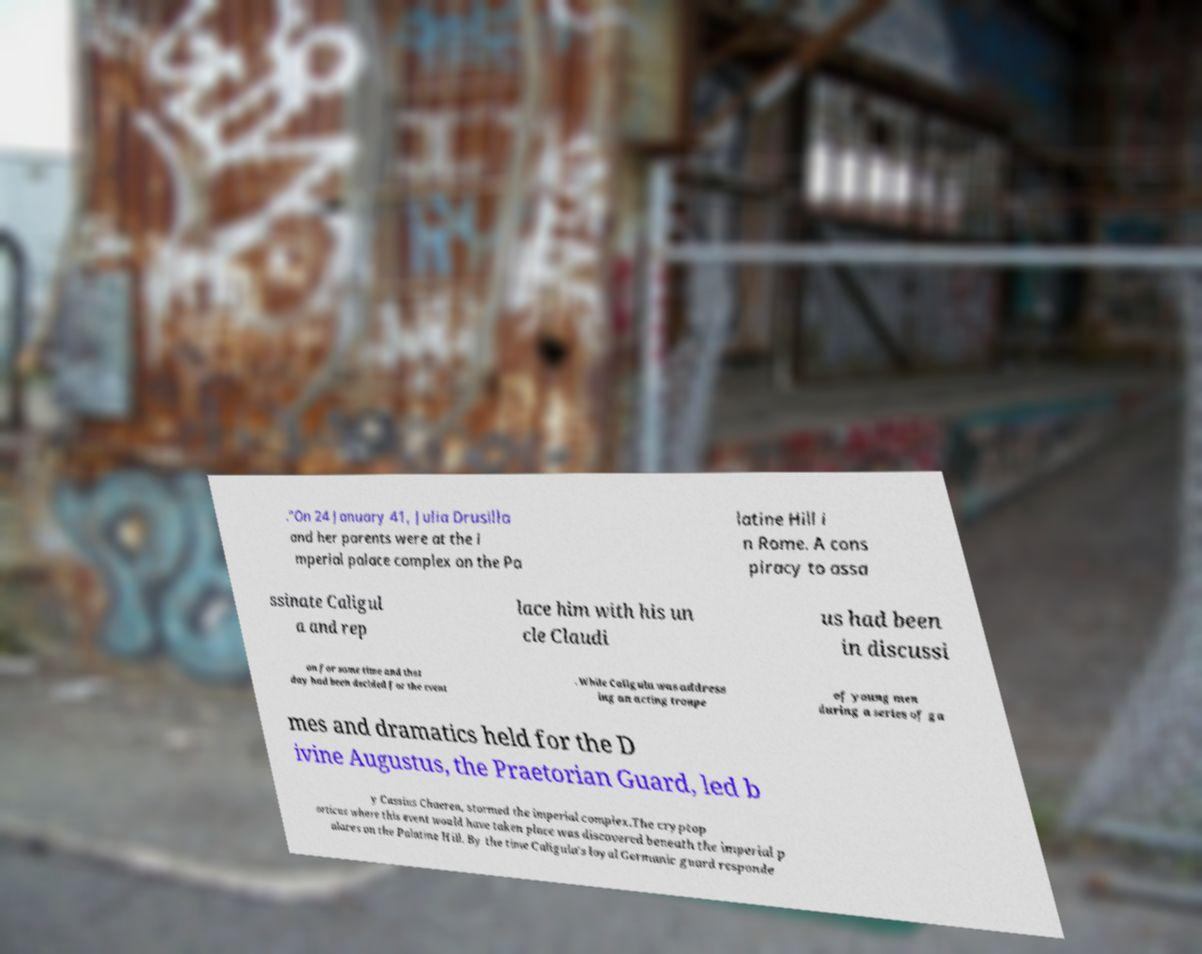Could you extract and type out the text from this image? ."On 24 January 41, Julia Drusilla and her parents were at the i mperial palace complex on the Pa latine Hill i n Rome. A cons piracy to assa ssinate Caligul a and rep lace him with his un cle Claudi us had been in discussi on for some time and that day had been decided for the event . While Caligula was address ing an acting troupe of young men during a series of ga mes and dramatics held for the D ivine Augustus, the Praetorian Guard, led b y Cassius Chaerea, stormed the imperial complex.The cryptop orticus where this event would have taken place was discovered beneath the imperial p alaces on the Palatine Hill. By the time Caligula's loyal Germanic guard responde 